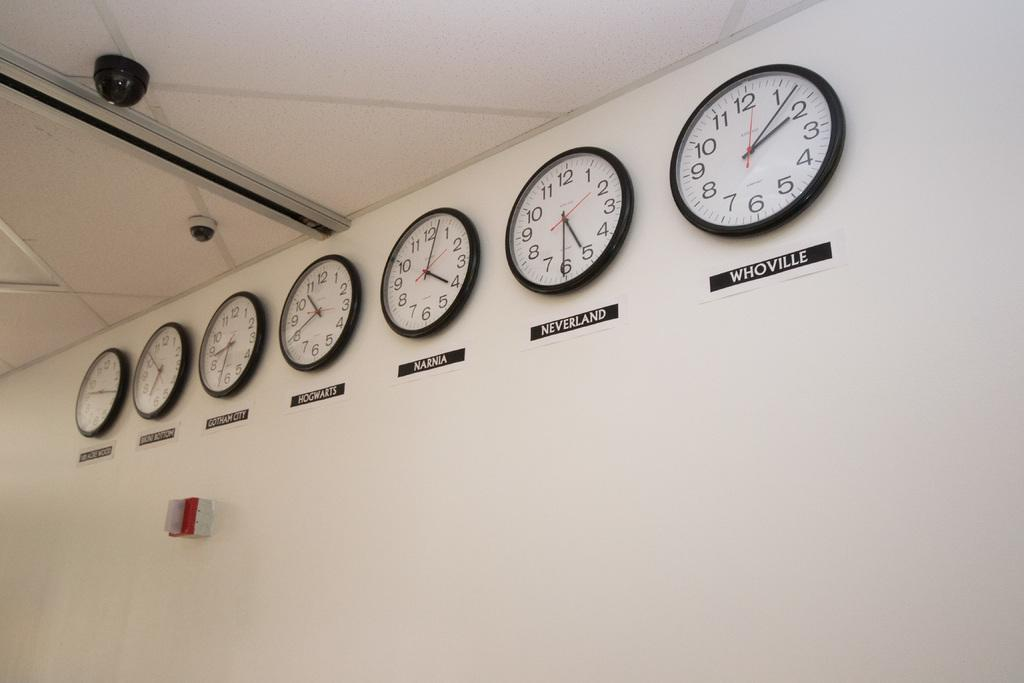Provide a one-sentence caption for the provided image. A collection of mounted clocks displaying times of various fictional places. 